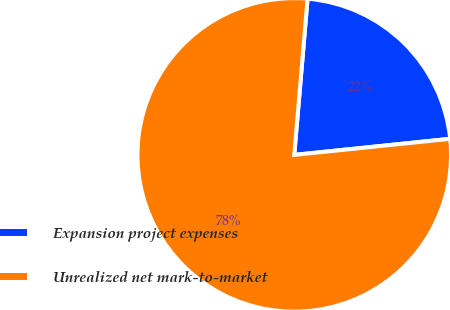Convert chart to OTSL. <chart><loc_0><loc_0><loc_500><loc_500><pie_chart><fcel>Expansion project expenses<fcel>Unrealized net mark-to-market<nl><fcel>22.01%<fcel>77.99%<nl></chart> 